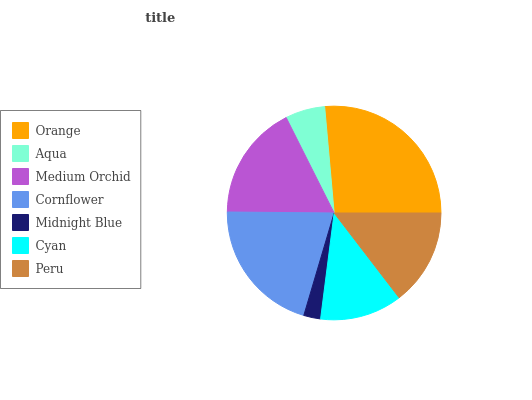Is Midnight Blue the minimum?
Answer yes or no. Yes. Is Orange the maximum?
Answer yes or no. Yes. Is Aqua the minimum?
Answer yes or no. No. Is Aqua the maximum?
Answer yes or no. No. Is Orange greater than Aqua?
Answer yes or no. Yes. Is Aqua less than Orange?
Answer yes or no. Yes. Is Aqua greater than Orange?
Answer yes or no. No. Is Orange less than Aqua?
Answer yes or no. No. Is Peru the high median?
Answer yes or no. Yes. Is Peru the low median?
Answer yes or no. Yes. Is Cyan the high median?
Answer yes or no. No. Is Medium Orchid the low median?
Answer yes or no. No. 